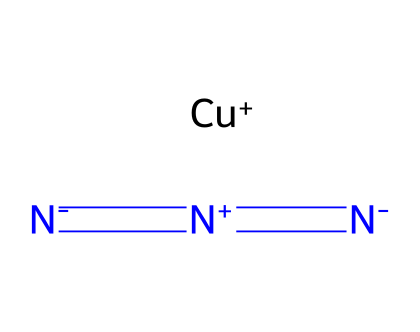What is the central atom in copper(I) azide? The central atom in this compound is copper, as it is indicated by the [Cu+] in the SMILES notation, highlighting the unequivocal presence of copper in the molecular structure.
Answer: copper How many nitrogen atoms are present in copper(I) azide? The SMILES representation shows three nitrogen atoms, as evidenced by the three instances of the nitrogen symbol (N) in the molecular structure.
Answer: three What type of bonds exist between the nitrogen atoms in copper(I) azide? The nitrogen atoms are connected by double bonds, as indicated by the "=" symbol between them, implying strong bonding interactions common to azides.
Answer: double bonds What is the oxidation state of copper in this compound? The oxidation state of copper in copper(I) azide is +1, represented clearly by the [Cu+] notation, designating its charge.
Answer: +1 How does the structure of copper(I) azide reflect its explosive properties? The molecular arrangement, particularly the presence of the azide functional group (N3), along with the copper center suggests high-energy interactions and stability in certain configurations, contributing to explosive characteristics.
Answer: explosive properties What is the overall charge of the copper(I) azide molecule? The overall charge is neutral, as the positive charge of copper (+1) offsets the negative charge contribution from the azide (N3) anion, leading to an electrically neutral compound when combined.
Answer: neutral 